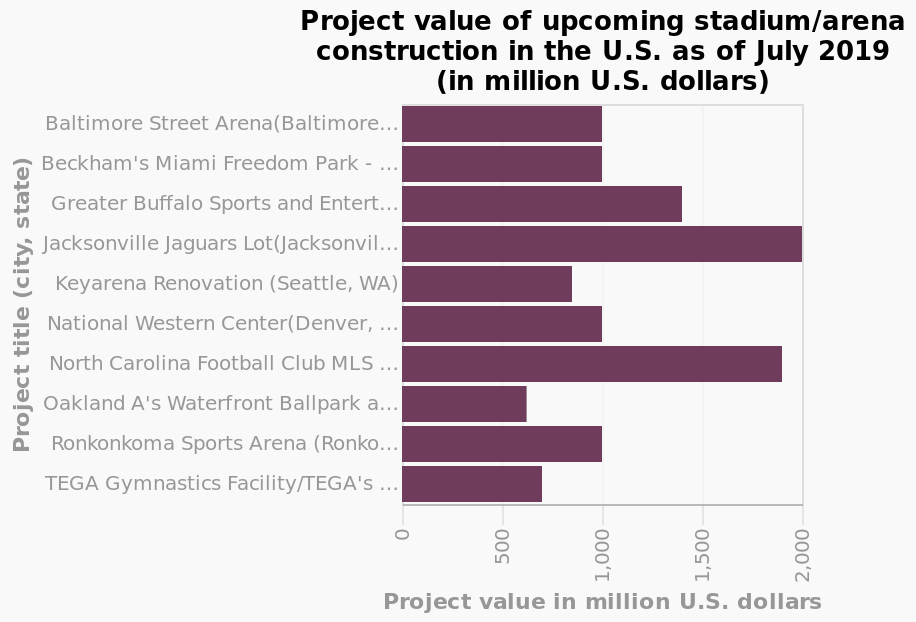<image>
please summary the statistics and relations of the chart North Carolina Football club and Jacksonville Jaguars have the highest spending by far. Twice as much as most of the other projects. What is the spending difference between North Carolina Football club and Jacksonville Jaguars compared to other projects?  North Carolina Football club and Jacksonville Jaguars spend twice as much as most of the other projects. Offer a thorough analysis of the image. All stadiums have a value of at least 500 million. The jacksonville jaguars lot is currently most expensive. Oakland A's is currently the cheapest. The majority of stadiums shown are equal to, or less than, 1000 million dollars in value. Are there any projects that spend more than North Carolina Football club and Jacksonville Jaguars?  No, North Carolina Football club and Jacksonville Jaguars have the highest spending by far. please describe the details of the chart This is a bar graph titled Project value of upcoming stadium/arena construction in the U.S. as of July 2019 (in million U.S. dollars). Project title (city, state) is drawn as a categorical scale from Baltimore Street Arena(Baltimore, MD) to TEGA Gymnastics Facility/TEGA's Kid's Superplex (Lubbock, TX) on the y-axis. There is a linear scale with a minimum of 0 and a maximum of 2,000 on the x-axis, labeled Project value in million U.S. dollars. Do North Carolina Football club and Jacksonville Jaguars have the lowest spending by far, half as much as most of the other projects? No.North Carolina Football club and Jacksonville Jaguars have the highest spending by far. Twice as much as most of the other projects. Is there a logarithmic scale with a minimum of 0 and a maximum of 5,000 on the x-axis, labeled Project value in billion U.S. dollars? No.This is a bar graph titled Project value of upcoming stadium/arena construction in the U.S. as of July 2019 (in million U.S. dollars). Project title (city, state) is drawn as a categorical scale from Baltimore Street Arena(Baltimore, MD) to TEGA Gymnastics Facility/TEGA's Kid's Superplex (Lubbock, TX) on the y-axis. There is a linear scale with a minimum of 0 and a maximum of 2,000 on the x-axis, labeled Project value in million U.S. dollars. 